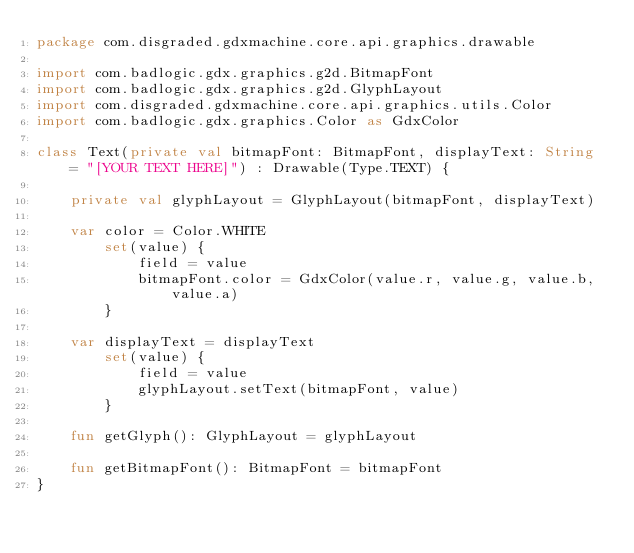<code> <loc_0><loc_0><loc_500><loc_500><_Kotlin_>package com.disgraded.gdxmachine.core.api.graphics.drawable

import com.badlogic.gdx.graphics.g2d.BitmapFont
import com.badlogic.gdx.graphics.g2d.GlyphLayout
import com.disgraded.gdxmachine.core.api.graphics.utils.Color
import com.badlogic.gdx.graphics.Color as GdxColor

class Text(private val bitmapFont: BitmapFont, displayText: String = "[YOUR TEXT HERE]") : Drawable(Type.TEXT) {

    private val glyphLayout = GlyphLayout(bitmapFont, displayText)

    var color = Color.WHITE
        set(value) {
            field = value
            bitmapFont.color = GdxColor(value.r, value.g, value.b, value.a)
        }

    var displayText = displayText
        set(value) {
            field = value
            glyphLayout.setText(bitmapFont, value)
        }

    fun getGlyph(): GlyphLayout = glyphLayout

    fun getBitmapFont(): BitmapFont = bitmapFont
}</code> 